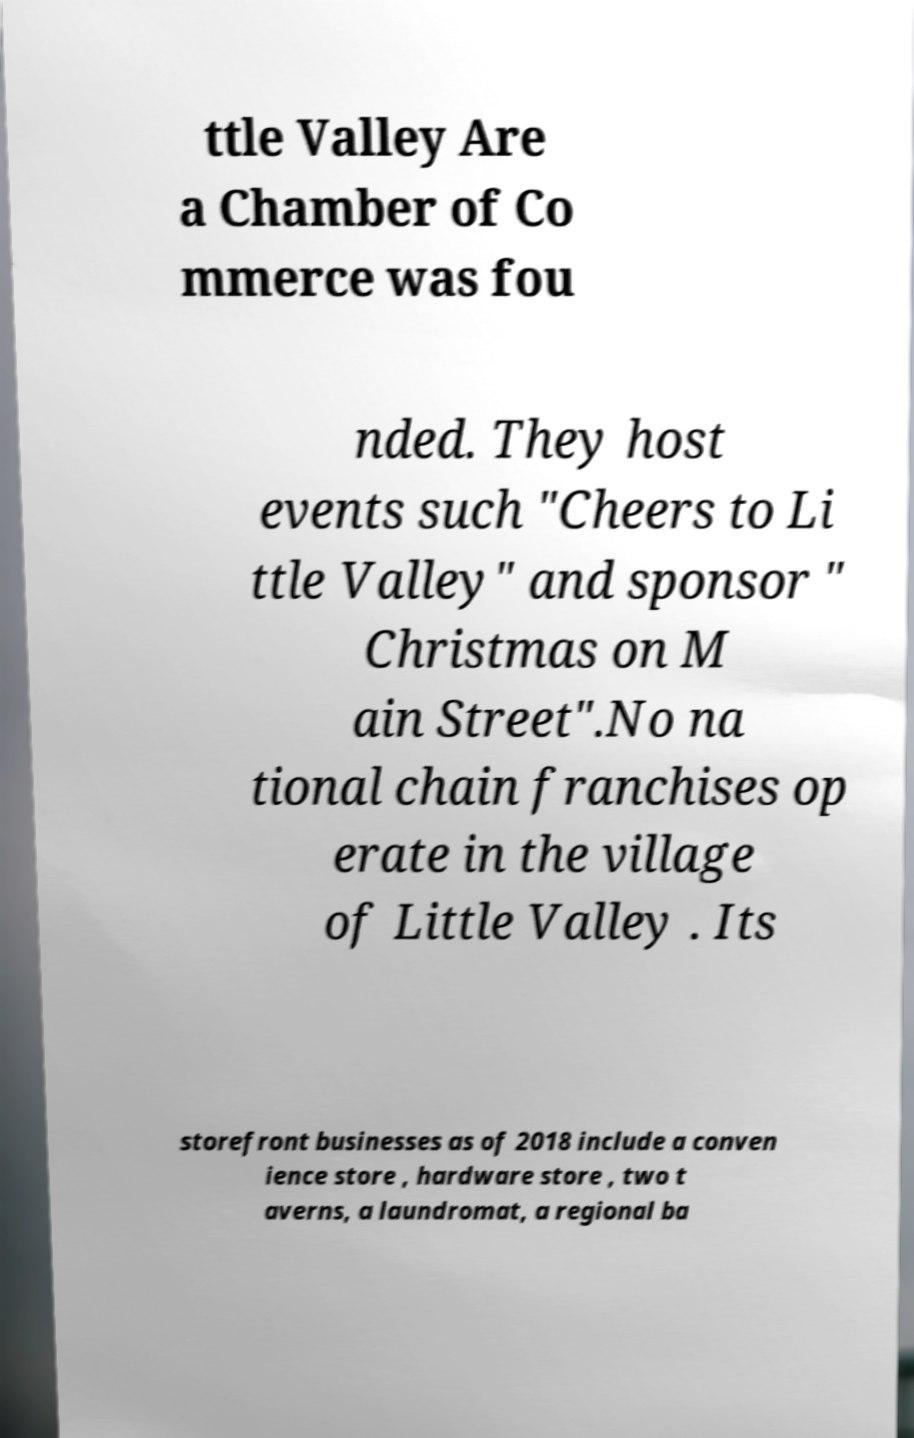Could you extract and type out the text from this image? ttle Valley Are a Chamber of Co mmerce was fou nded. They host events such "Cheers to Li ttle Valley" and sponsor " Christmas on M ain Street".No na tional chain franchises op erate in the village of Little Valley . Its storefront businesses as of 2018 include a conven ience store , hardware store , two t averns, a laundromat, a regional ba 